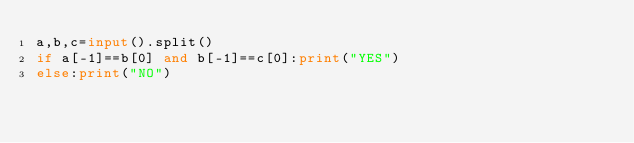Convert code to text. <code><loc_0><loc_0><loc_500><loc_500><_Python_>a,b,c=input().split()
if a[-1]==b[0] and b[-1]==c[0]:print("YES")
else:print("NO")</code> 